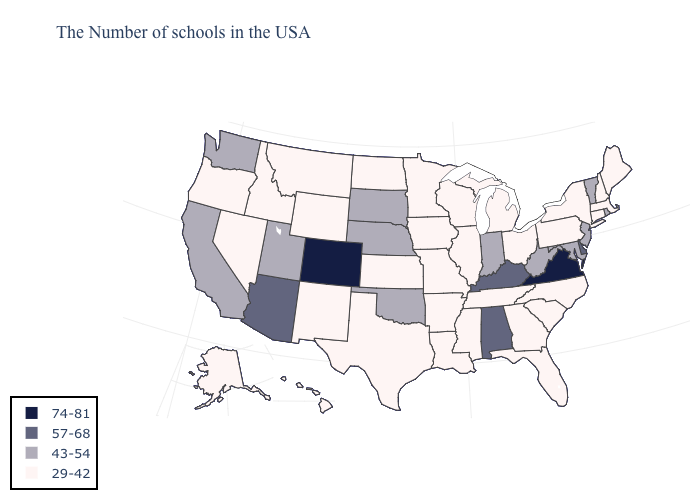Does the map have missing data?
Short answer required. No. What is the value of Pennsylvania?
Be succinct. 29-42. What is the value of South Dakota?
Keep it brief. 43-54. Name the states that have a value in the range 29-42?
Give a very brief answer. Maine, Massachusetts, New Hampshire, Connecticut, New York, Pennsylvania, North Carolina, South Carolina, Ohio, Florida, Georgia, Michigan, Tennessee, Wisconsin, Illinois, Mississippi, Louisiana, Missouri, Arkansas, Minnesota, Iowa, Kansas, Texas, North Dakota, Wyoming, New Mexico, Montana, Idaho, Nevada, Oregon, Alaska, Hawaii. Among the states that border North Dakota , does South Dakota have the highest value?
Give a very brief answer. Yes. What is the value of Florida?
Answer briefly. 29-42. What is the value of Indiana?
Write a very short answer. 43-54. Does Delaware have the highest value in the South?
Keep it brief. No. Does the map have missing data?
Quick response, please. No. Name the states that have a value in the range 57-68?
Quick response, please. Delaware, Kentucky, Alabama, Arizona. What is the value of Florida?
Answer briefly. 29-42. Name the states that have a value in the range 57-68?
Write a very short answer. Delaware, Kentucky, Alabama, Arizona. What is the highest value in states that border North Dakota?
Quick response, please. 43-54. Which states have the lowest value in the West?
Concise answer only. Wyoming, New Mexico, Montana, Idaho, Nevada, Oregon, Alaska, Hawaii. What is the value of Massachusetts?
Quick response, please. 29-42. 